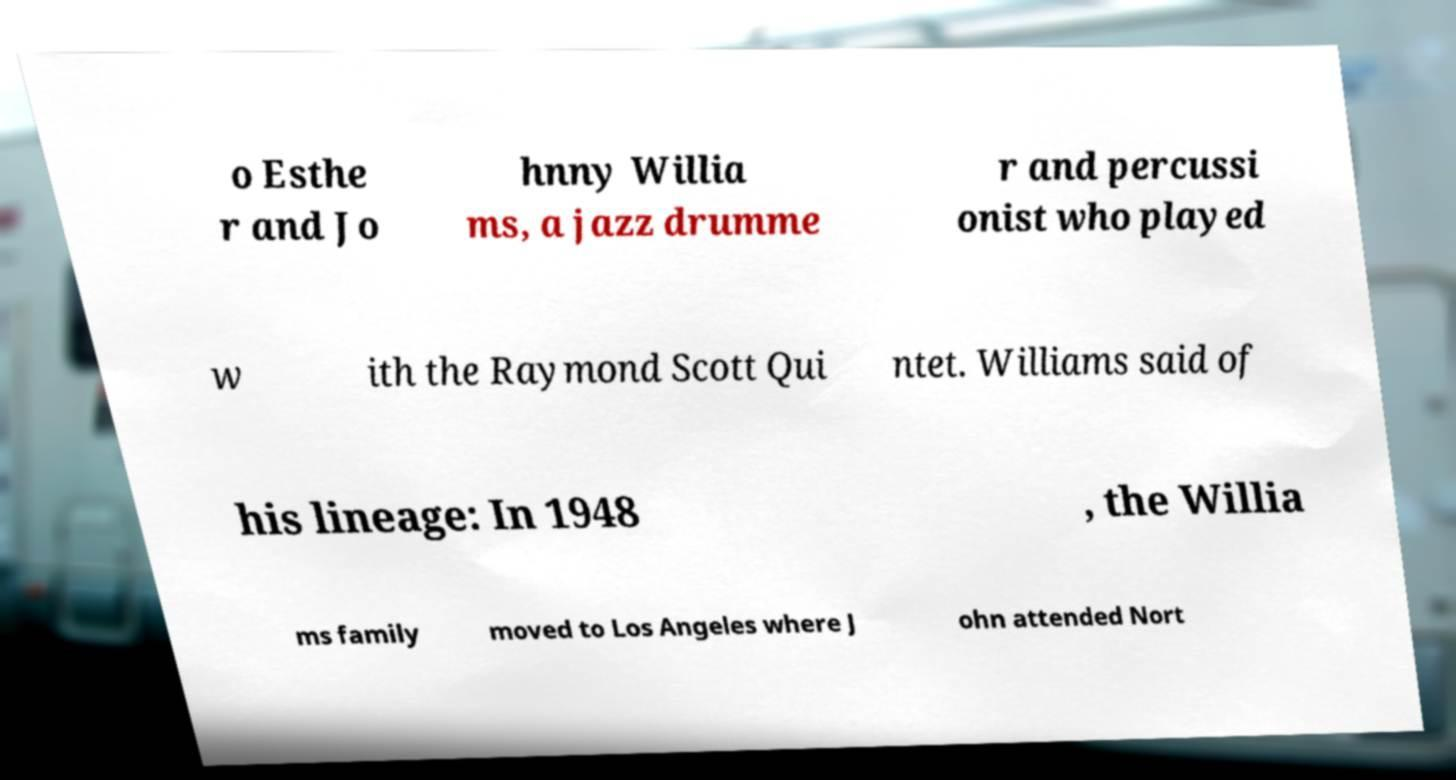Can you accurately transcribe the text from the provided image for me? o Esthe r and Jo hnny Willia ms, a jazz drumme r and percussi onist who played w ith the Raymond Scott Qui ntet. Williams said of his lineage: In 1948 , the Willia ms family moved to Los Angeles where J ohn attended Nort 